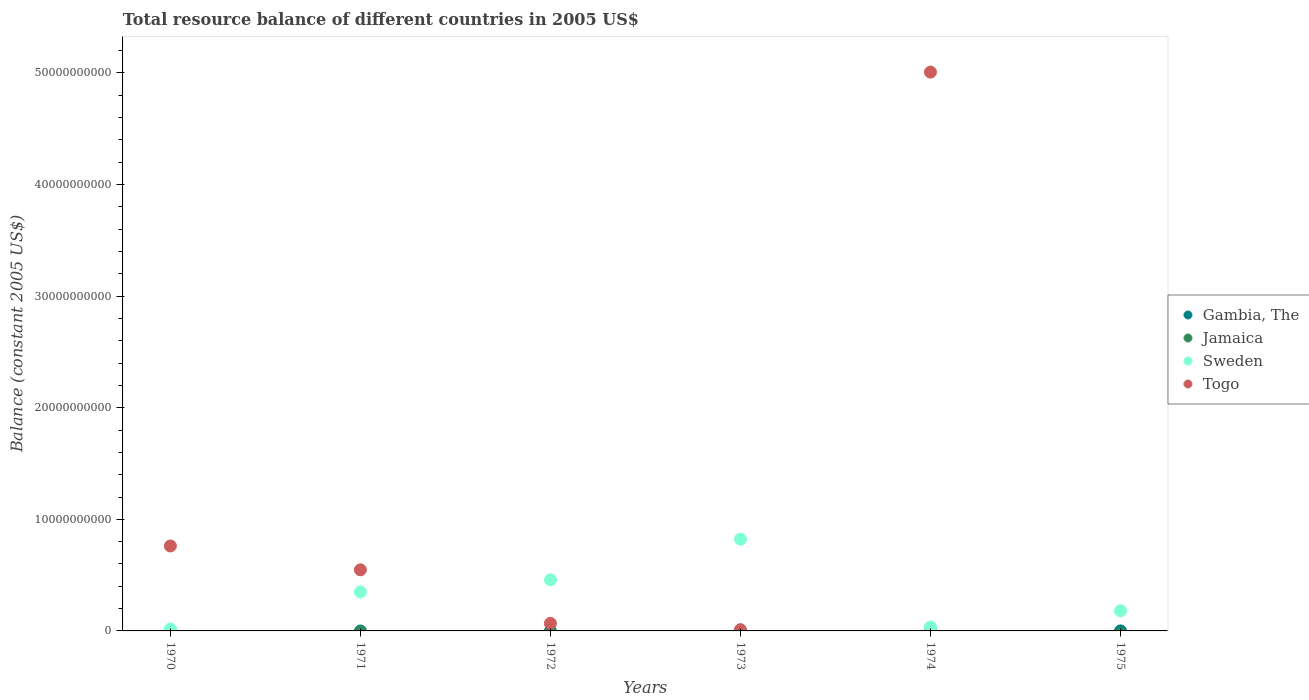Is the number of dotlines equal to the number of legend labels?
Your answer should be very brief. No. Across all years, what is the maximum total resource balance in Gambia, The?
Make the answer very short. 2.28e+06. In which year was the total resource balance in Togo maximum?
Give a very brief answer. 1974. What is the total total resource balance in Gambia, The in the graph?
Make the answer very short. 2.28e+06. What is the difference between the total resource balance in Sweden in 1974 and that in 1975?
Keep it short and to the point. -1.46e+09. What is the average total resource balance in Togo per year?
Make the answer very short. 1.07e+1. In the year 1971, what is the difference between the total resource balance in Sweden and total resource balance in Togo?
Keep it short and to the point. -1.98e+09. What is the ratio of the total resource balance in Sweden in 1970 to that in 1973?
Provide a short and direct response. 0.02. Is the total resource balance in Togo in 1973 less than that in 1974?
Provide a short and direct response. Yes. Is the difference between the total resource balance in Sweden in 1972 and 1973 greater than the difference between the total resource balance in Togo in 1972 and 1973?
Provide a short and direct response. No. What is the difference between the highest and the second highest total resource balance in Sweden?
Provide a succinct answer. 3.65e+09. What is the difference between the highest and the lowest total resource balance in Gambia, The?
Give a very brief answer. 2.28e+06. Is it the case that in every year, the sum of the total resource balance in Togo and total resource balance in Sweden  is greater than the sum of total resource balance in Jamaica and total resource balance in Gambia, The?
Make the answer very short. Yes. Is it the case that in every year, the sum of the total resource balance in Gambia, The and total resource balance in Jamaica  is greater than the total resource balance in Sweden?
Offer a very short reply. No. Is the total resource balance in Gambia, The strictly less than the total resource balance in Jamaica over the years?
Give a very brief answer. No. How many dotlines are there?
Offer a terse response. 3. How many years are there in the graph?
Ensure brevity in your answer.  6. What is the difference between two consecutive major ticks on the Y-axis?
Your response must be concise. 1.00e+1. Are the values on the major ticks of Y-axis written in scientific E-notation?
Provide a succinct answer. No. Does the graph contain any zero values?
Offer a terse response. Yes. How many legend labels are there?
Ensure brevity in your answer.  4. How are the legend labels stacked?
Provide a succinct answer. Vertical. What is the title of the graph?
Ensure brevity in your answer.  Total resource balance of different countries in 2005 US$. Does "Andorra" appear as one of the legend labels in the graph?
Give a very brief answer. No. What is the label or title of the X-axis?
Provide a succinct answer. Years. What is the label or title of the Y-axis?
Your answer should be compact. Balance (constant 2005 US$). What is the Balance (constant 2005 US$) in Jamaica in 1970?
Keep it short and to the point. 0. What is the Balance (constant 2005 US$) in Sweden in 1970?
Provide a succinct answer. 1.72e+08. What is the Balance (constant 2005 US$) of Togo in 1970?
Offer a terse response. 7.61e+09. What is the Balance (constant 2005 US$) of Gambia, The in 1971?
Your answer should be very brief. 0. What is the Balance (constant 2005 US$) in Sweden in 1971?
Make the answer very short. 3.50e+09. What is the Balance (constant 2005 US$) in Togo in 1971?
Your answer should be very brief. 5.48e+09. What is the Balance (constant 2005 US$) in Gambia, The in 1972?
Your answer should be compact. 0. What is the Balance (constant 2005 US$) in Sweden in 1972?
Keep it short and to the point. 4.58e+09. What is the Balance (constant 2005 US$) of Togo in 1972?
Your answer should be compact. 6.77e+08. What is the Balance (constant 2005 US$) in Jamaica in 1973?
Offer a terse response. 0. What is the Balance (constant 2005 US$) in Sweden in 1973?
Your answer should be very brief. 8.23e+09. What is the Balance (constant 2005 US$) of Togo in 1973?
Offer a terse response. 1.13e+08. What is the Balance (constant 2005 US$) of Gambia, The in 1974?
Your answer should be very brief. 0. What is the Balance (constant 2005 US$) in Sweden in 1974?
Your answer should be very brief. 3.47e+08. What is the Balance (constant 2005 US$) of Togo in 1974?
Ensure brevity in your answer.  5.01e+1. What is the Balance (constant 2005 US$) in Gambia, The in 1975?
Make the answer very short. 2.28e+06. What is the Balance (constant 2005 US$) in Jamaica in 1975?
Make the answer very short. 0. What is the Balance (constant 2005 US$) in Sweden in 1975?
Provide a short and direct response. 1.81e+09. Across all years, what is the maximum Balance (constant 2005 US$) of Gambia, The?
Offer a very short reply. 2.28e+06. Across all years, what is the maximum Balance (constant 2005 US$) in Sweden?
Your answer should be compact. 8.23e+09. Across all years, what is the maximum Balance (constant 2005 US$) of Togo?
Give a very brief answer. 5.01e+1. Across all years, what is the minimum Balance (constant 2005 US$) in Gambia, The?
Give a very brief answer. 0. Across all years, what is the minimum Balance (constant 2005 US$) in Sweden?
Offer a terse response. 1.72e+08. Across all years, what is the minimum Balance (constant 2005 US$) of Togo?
Offer a very short reply. 0. What is the total Balance (constant 2005 US$) of Gambia, The in the graph?
Your response must be concise. 2.28e+06. What is the total Balance (constant 2005 US$) of Sweden in the graph?
Ensure brevity in your answer.  1.86e+1. What is the total Balance (constant 2005 US$) in Togo in the graph?
Give a very brief answer. 6.40e+1. What is the difference between the Balance (constant 2005 US$) in Sweden in 1970 and that in 1971?
Your answer should be compact. -3.32e+09. What is the difference between the Balance (constant 2005 US$) of Togo in 1970 and that in 1971?
Your answer should be compact. 2.14e+09. What is the difference between the Balance (constant 2005 US$) in Sweden in 1970 and that in 1972?
Your answer should be very brief. -4.41e+09. What is the difference between the Balance (constant 2005 US$) of Togo in 1970 and that in 1972?
Make the answer very short. 6.94e+09. What is the difference between the Balance (constant 2005 US$) in Sweden in 1970 and that in 1973?
Ensure brevity in your answer.  -8.06e+09. What is the difference between the Balance (constant 2005 US$) of Togo in 1970 and that in 1973?
Provide a succinct answer. 7.50e+09. What is the difference between the Balance (constant 2005 US$) of Sweden in 1970 and that in 1974?
Provide a succinct answer. -1.75e+08. What is the difference between the Balance (constant 2005 US$) of Togo in 1970 and that in 1974?
Your answer should be compact. -4.25e+1. What is the difference between the Balance (constant 2005 US$) in Sweden in 1970 and that in 1975?
Make the answer very short. -1.64e+09. What is the difference between the Balance (constant 2005 US$) of Sweden in 1971 and that in 1972?
Keep it short and to the point. -1.09e+09. What is the difference between the Balance (constant 2005 US$) of Togo in 1971 and that in 1972?
Make the answer very short. 4.80e+09. What is the difference between the Balance (constant 2005 US$) in Sweden in 1971 and that in 1973?
Give a very brief answer. -4.73e+09. What is the difference between the Balance (constant 2005 US$) of Togo in 1971 and that in 1973?
Your answer should be compact. 5.36e+09. What is the difference between the Balance (constant 2005 US$) of Sweden in 1971 and that in 1974?
Your answer should be very brief. 3.15e+09. What is the difference between the Balance (constant 2005 US$) of Togo in 1971 and that in 1974?
Keep it short and to the point. -4.46e+1. What is the difference between the Balance (constant 2005 US$) of Sweden in 1971 and that in 1975?
Your response must be concise. 1.69e+09. What is the difference between the Balance (constant 2005 US$) in Sweden in 1972 and that in 1973?
Offer a very short reply. -3.65e+09. What is the difference between the Balance (constant 2005 US$) of Togo in 1972 and that in 1973?
Provide a succinct answer. 5.64e+08. What is the difference between the Balance (constant 2005 US$) in Sweden in 1972 and that in 1974?
Offer a very short reply. 4.23e+09. What is the difference between the Balance (constant 2005 US$) in Togo in 1972 and that in 1974?
Your answer should be compact. -4.94e+1. What is the difference between the Balance (constant 2005 US$) of Sweden in 1972 and that in 1975?
Your answer should be compact. 2.77e+09. What is the difference between the Balance (constant 2005 US$) of Sweden in 1973 and that in 1974?
Give a very brief answer. 7.88e+09. What is the difference between the Balance (constant 2005 US$) of Togo in 1973 and that in 1974?
Offer a terse response. -5.00e+1. What is the difference between the Balance (constant 2005 US$) in Sweden in 1973 and that in 1975?
Provide a succinct answer. 6.42e+09. What is the difference between the Balance (constant 2005 US$) of Sweden in 1974 and that in 1975?
Make the answer very short. -1.46e+09. What is the difference between the Balance (constant 2005 US$) of Sweden in 1970 and the Balance (constant 2005 US$) of Togo in 1971?
Ensure brevity in your answer.  -5.30e+09. What is the difference between the Balance (constant 2005 US$) of Sweden in 1970 and the Balance (constant 2005 US$) of Togo in 1972?
Make the answer very short. -5.04e+08. What is the difference between the Balance (constant 2005 US$) in Sweden in 1970 and the Balance (constant 2005 US$) in Togo in 1973?
Your answer should be compact. 5.96e+07. What is the difference between the Balance (constant 2005 US$) in Sweden in 1970 and the Balance (constant 2005 US$) in Togo in 1974?
Provide a succinct answer. -4.99e+1. What is the difference between the Balance (constant 2005 US$) of Sweden in 1971 and the Balance (constant 2005 US$) of Togo in 1972?
Make the answer very short. 2.82e+09. What is the difference between the Balance (constant 2005 US$) in Sweden in 1971 and the Balance (constant 2005 US$) in Togo in 1973?
Your answer should be very brief. 3.38e+09. What is the difference between the Balance (constant 2005 US$) in Sweden in 1971 and the Balance (constant 2005 US$) in Togo in 1974?
Offer a terse response. -4.66e+1. What is the difference between the Balance (constant 2005 US$) of Sweden in 1972 and the Balance (constant 2005 US$) of Togo in 1973?
Keep it short and to the point. 4.47e+09. What is the difference between the Balance (constant 2005 US$) in Sweden in 1972 and the Balance (constant 2005 US$) in Togo in 1974?
Provide a short and direct response. -4.55e+1. What is the difference between the Balance (constant 2005 US$) in Sweden in 1973 and the Balance (constant 2005 US$) in Togo in 1974?
Offer a terse response. -4.18e+1. What is the average Balance (constant 2005 US$) of Gambia, The per year?
Give a very brief answer. 3.80e+05. What is the average Balance (constant 2005 US$) in Jamaica per year?
Offer a very short reply. 0. What is the average Balance (constant 2005 US$) in Sweden per year?
Provide a short and direct response. 3.11e+09. What is the average Balance (constant 2005 US$) in Togo per year?
Keep it short and to the point. 1.07e+1. In the year 1970, what is the difference between the Balance (constant 2005 US$) of Sweden and Balance (constant 2005 US$) of Togo?
Your response must be concise. -7.44e+09. In the year 1971, what is the difference between the Balance (constant 2005 US$) of Sweden and Balance (constant 2005 US$) of Togo?
Provide a short and direct response. -1.98e+09. In the year 1972, what is the difference between the Balance (constant 2005 US$) in Sweden and Balance (constant 2005 US$) in Togo?
Your answer should be compact. 3.90e+09. In the year 1973, what is the difference between the Balance (constant 2005 US$) in Sweden and Balance (constant 2005 US$) in Togo?
Offer a terse response. 8.12e+09. In the year 1974, what is the difference between the Balance (constant 2005 US$) of Sweden and Balance (constant 2005 US$) of Togo?
Offer a very short reply. -4.97e+1. In the year 1975, what is the difference between the Balance (constant 2005 US$) of Gambia, The and Balance (constant 2005 US$) of Sweden?
Your answer should be very brief. -1.81e+09. What is the ratio of the Balance (constant 2005 US$) of Sweden in 1970 to that in 1971?
Keep it short and to the point. 0.05. What is the ratio of the Balance (constant 2005 US$) in Togo in 1970 to that in 1971?
Your response must be concise. 1.39. What is the ratio of the Balance (constant 2005 US$) in Sweden in 1970 to that in 1972?
Provide a short and direct response. 0.04. What is the ratio of the Balance (constant 2005 US$) in Togo in 1970 to that in 1972?
Offer a terse response. 11.25. What is the ratio of the Balance (constant 2005 US$) of Sweden in 1970 to that in 1973?
Offer a very short reply. 0.02. What is the ratio of the Balance (constant 2005 US$) in Togo in 1970 to that in 1973?
Your answer should be compact. 67.51. What is the ratio of the Balance (constant 2005 US$) of Sweden in 1970 to that in 1974?
Offer a very short reply. 0.5. What is the ratio of the Balance (constant 2005 US$) of Togo in 1970 to that in 1974?
Provide a short and direct response. 0.15. What is the ratio of the Balance (constant 2005 US$) in Sweden in 1970 to that in 1975?
Your answer should be compact. 0.1. What is the ratio of the Balance (constant 2005 US$) in Sweden in 1971 to that in 1972?
Ensure brevity in your answer.  0.76. What is the ratio of the Balance (constant 2005 US$) in Togo in 1971 to that in 1972?
Make the answer very short. 8.09. What is the ratio of the Balance (constant 2005 US$) in Sweden in 1971 to that in 1973?
Your answer should be compact. 0.42. What is the ratio of the Balance (constant 2005 US$) of Togo in 1971 to that in 1973?
Provide a succinct answer. 48.55. What is the ratio of the Balance (constant 2005 US$) of Sweden in 1971 to that in 1974?
Offer a very short reply. 10.07. What is the ratio of the Balance (constant 2005 US$) of Togo in 1971 to that in 1974?
Give a very brief answer. 0.11. What is the ratio of the Balance (constant 2005 US$) in Sweden in 1971 to that in 1975?
Provide a short and direct response. 1.93. What is the ratio of the Balance (constant 2005 US$) of Sweden in 1972 to that in 1973?
Offer a very short reply. 0.56. What is the ratio of the Balance (constant 2005 US$) of Togo in 1972 to that in 1973?
Make the answer very short. 6. What is the ratio of the Balance (constant 2005 US$) in Sweden in 1972 to that in 1974?
Offer a very short reply. 13.19. What is the ratio of the Balance (constant 2005 US$) in Togo in 1972 to that in 1974?
Your answer should be very brief. 0.01. What is the ratio of the Balance (constant 2005 US$) in Sweden in 1972 to that in 1975?
Provide a succinct answer. 2.53. What is the ratio of the Balance (constant 2005 US$) in Sweden in 1973 to that in 1974?
Provide a succinct answer. 23.7. What is the ratio of the Balance (constant 2005 US$) in Togo in 1973 to that in 1974?
Provide a succinct answer. 0. What is the ratio of the Balance (constant 2005 US$) in Sweden in 1973 to that in 1975?
Provide a short and direct response. 4.55. What is the ratio of the Balance (constant 2005 US$) in Sweden in 1974 to that in 1975?
Make the answer very short. 0.19. What is the difference between the highest and the second highest Balance (constant 2005 US$) in Sweden?
Ensure brevity in your answer.  3.65e+09. What is the difference between the highest and the second highest Balance (constant 2005 US$) in Togo?
Your answer should be very brief. 4.25e+1. What is the difference between the highest and the lowest Balance (constant 2005 US$) in Gambia, The?
Your answer should be compact. 2.28e+06. What is the difference between the highest and the lowest Balance (constant 2005 US$) in Sweden?
Your answer should be compact. 8.06e+09. What is the difference between the highest and the lowest Balance (constant 2005 US$) in Togo?
Offer a very short reply. 5.01e+1. 